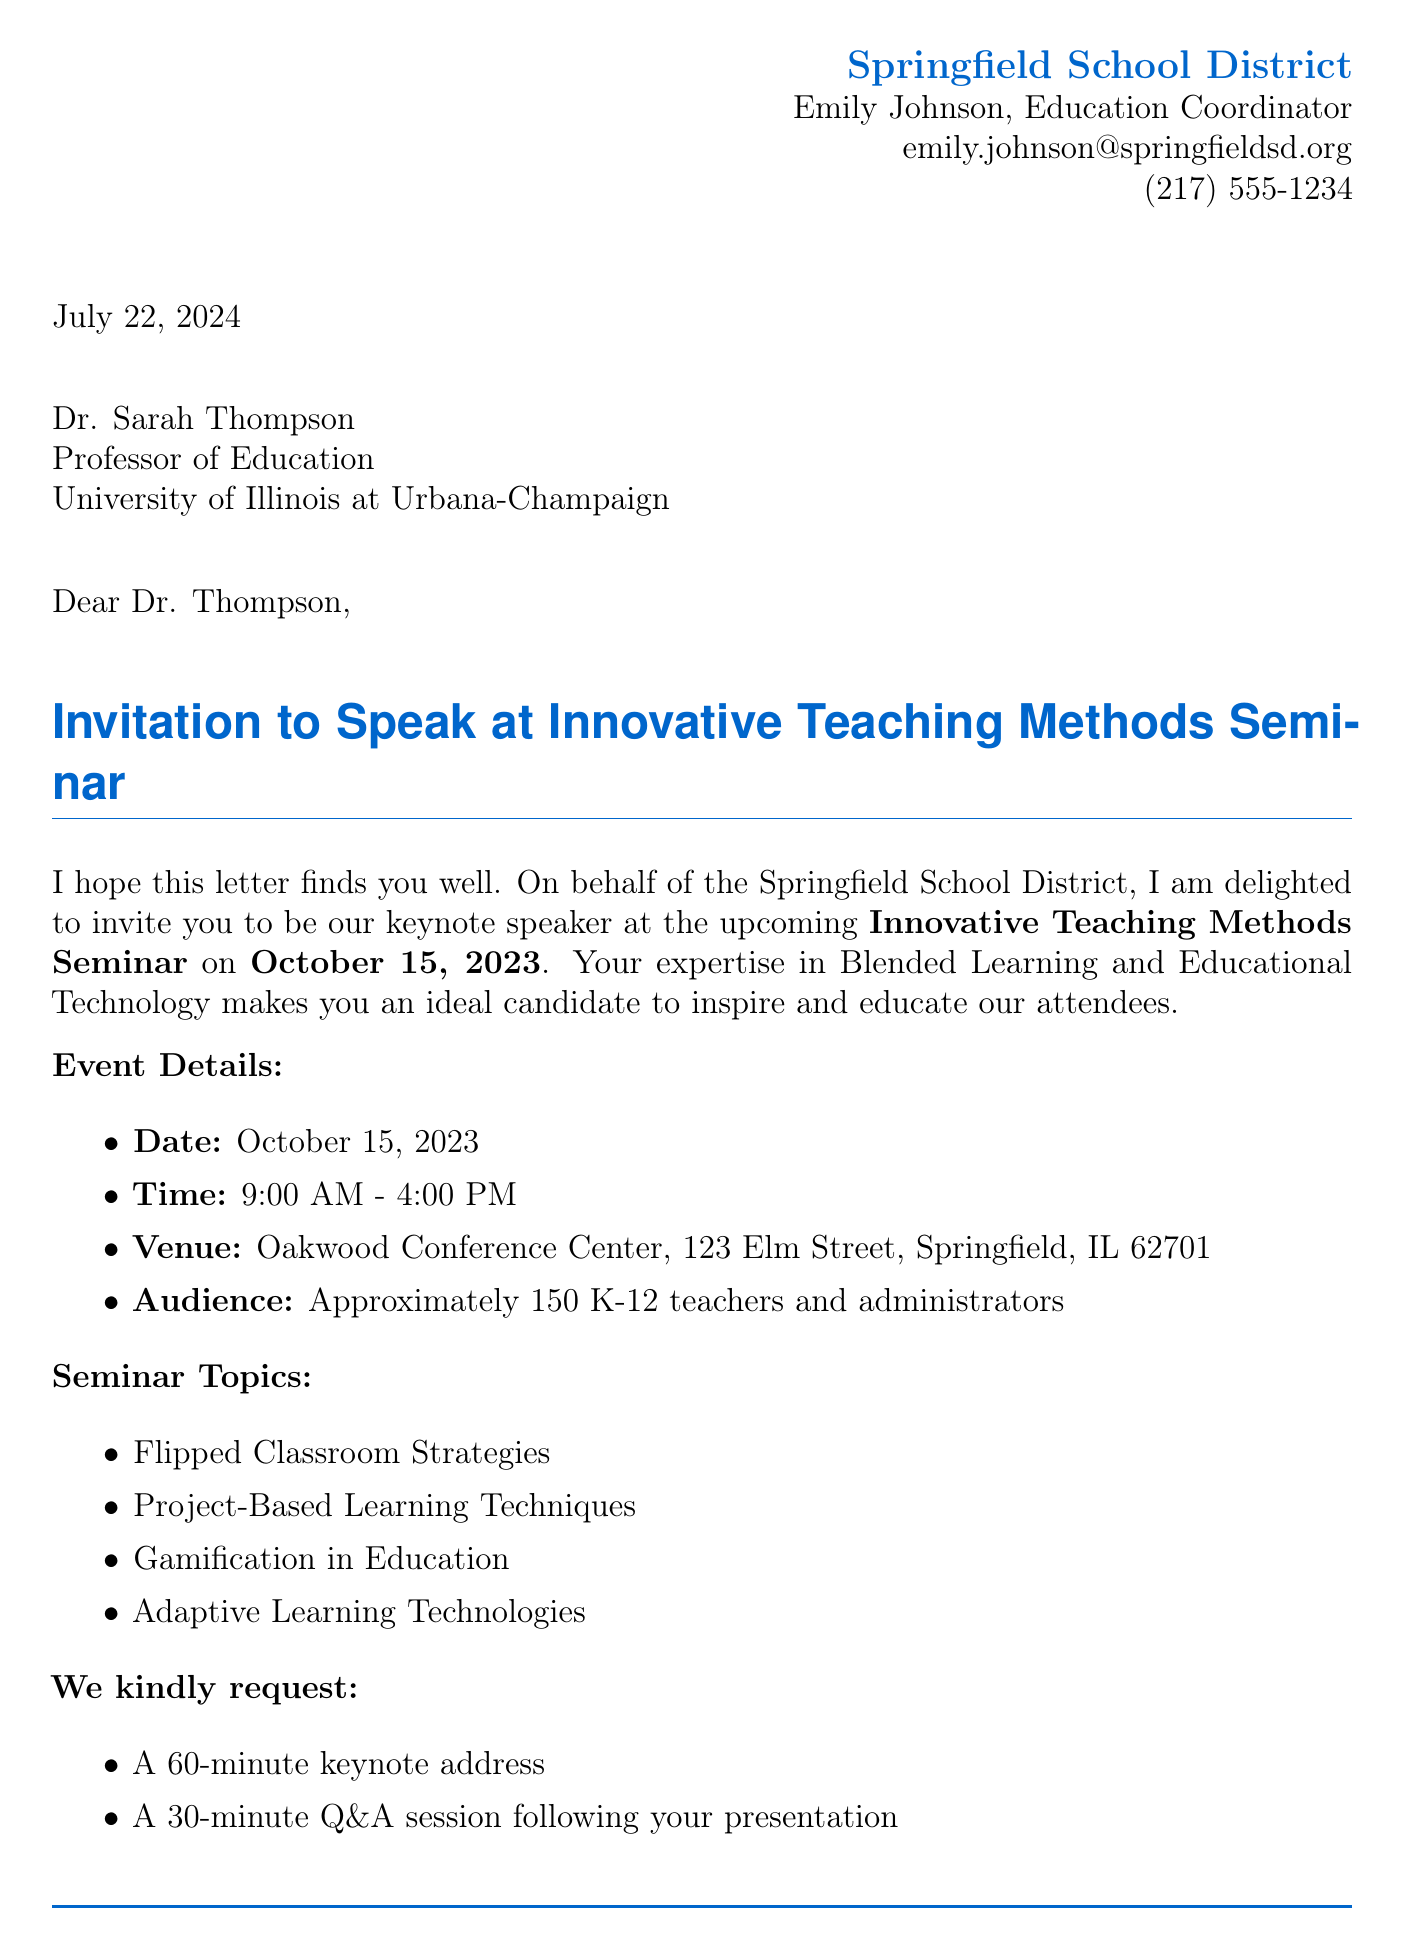What is the name of the seminar? The name of the seminar is mentioned in the document, specifically in the invitation title.
Answer: Innovative Teaching Methods Seminar What is the date of the event? The document clearly states the event date in the "Event Details" section.
Answer: October 15, 2023 Who is the guest speaker? The name of the guest speaker is provided at the beginning of the letter.
Answer: Dr. Sarah Thompson How long is the keynote address? The length of the keynote address is specifically requested in the seminar invitation.
Answer: 60-minute What is the honorarium amount offered? The honorarium amount is indicated in the "We are pleased to offer" section.
Answer: $1,000 What audience is the seminar targeting? The target audience is specified in the "Event Details" section of the document.
Answer: K-12 teachers and administrators What is the confirmation response deadline? The deadline for confirmation is mentioned towards the end of the letter.
Answer: August 31, 2023 Where will the seminar take place? The venue for the seminar is provided in the "Event Details" section.
Answer: Oakwood Conference Center What is included in the logistics for the guest speaker? The logistics section outlines travel arrangements, accommodation, and honorarium for the guest speaker.
Answer: Complimentary transportation, one night stay at the Hilton Garden Inn, $1,000 